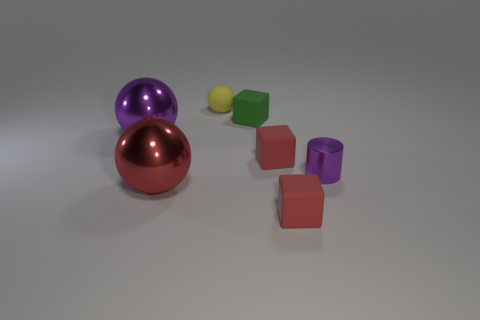Add 2 gray matte spheres. How many objects exist? 9 Subtract all cubes. How many objects are left? 4 Subtract 1 purple cylinders. How many objects are left? 6 Subtract all large purple objects. Subtract all large metallic things. How many objects are left? 4 Add 7 tiny rubber cubes. How many tiny rubber cubes are left? 10 Add 7 big purple spheres. How many big purple spheres exist? 8 